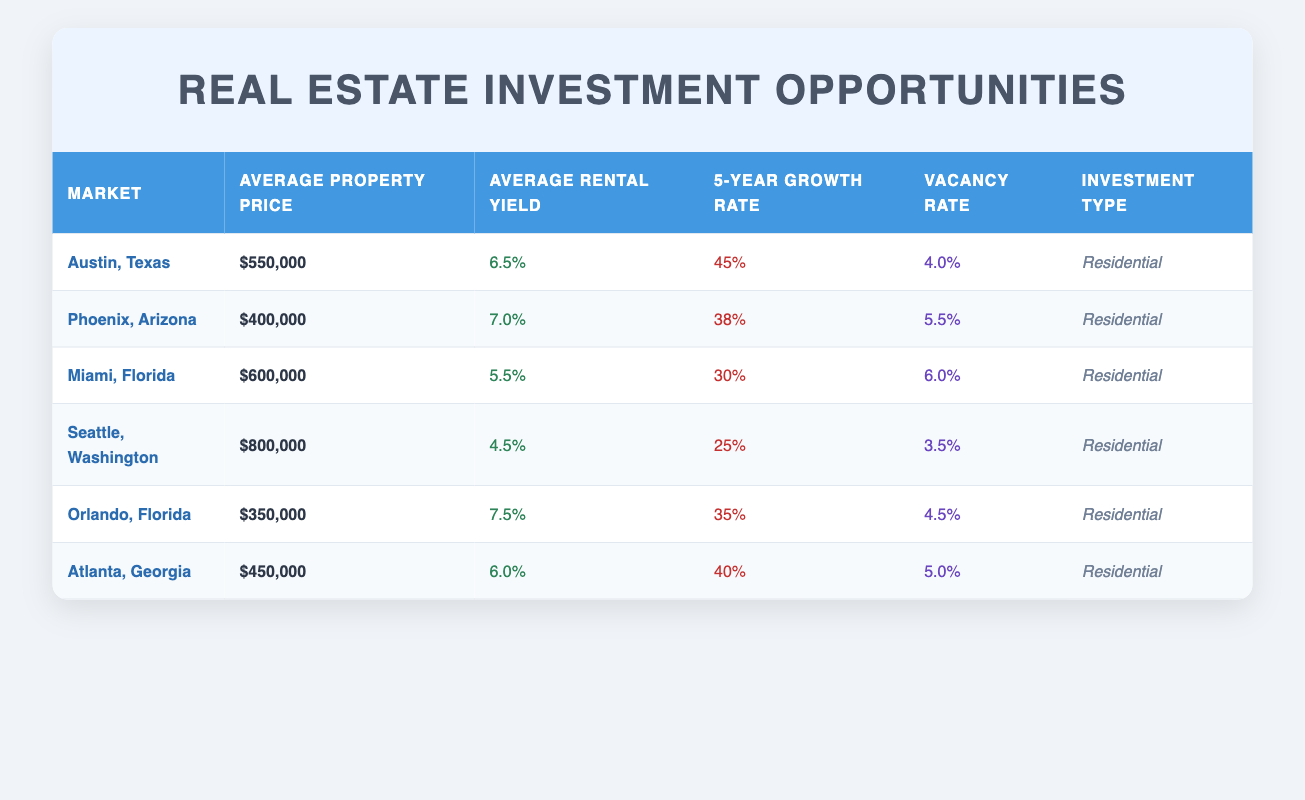What is the average property price in Orlando, Florida? The table lists the average property price for Orlando, Florida as $350,000.
Answer: $350,000 Which market has the highest average rental yield? By comparing the average rental yields in the table, Orlando, Florida has the highest average rental yield at 7.5%.
Answer: Orlando, Florida What is the 5-year growth rate difference between Austin, Texas and Seattle, Washington? Austin, Texas has a growth rate of 45%, while Seattle, Washington has a growth rate of 25%. The difference is 45% - 25% = 20%.
Answer: 20% Is the vacancy rate in Phoenix, Arizona higher than in Atlanta, Georgia? The vacancy rate in Phoenix is 5.5%, while in Atlanta it is 5.0%. Since 5.5% is greater than 5.0%, the statement is true.
Answer: Yes What is the average property price for markets with a rental yield above 6%? The markets with a rental yield above 6% are Austin (550,000), Phoenix (400,000), Orlando (350,000), and Atlanta (450,000). The average is (550,000 + 400,000 + 350,000 + 450,000) / 4 = 437,500.
Answer: 437,500 